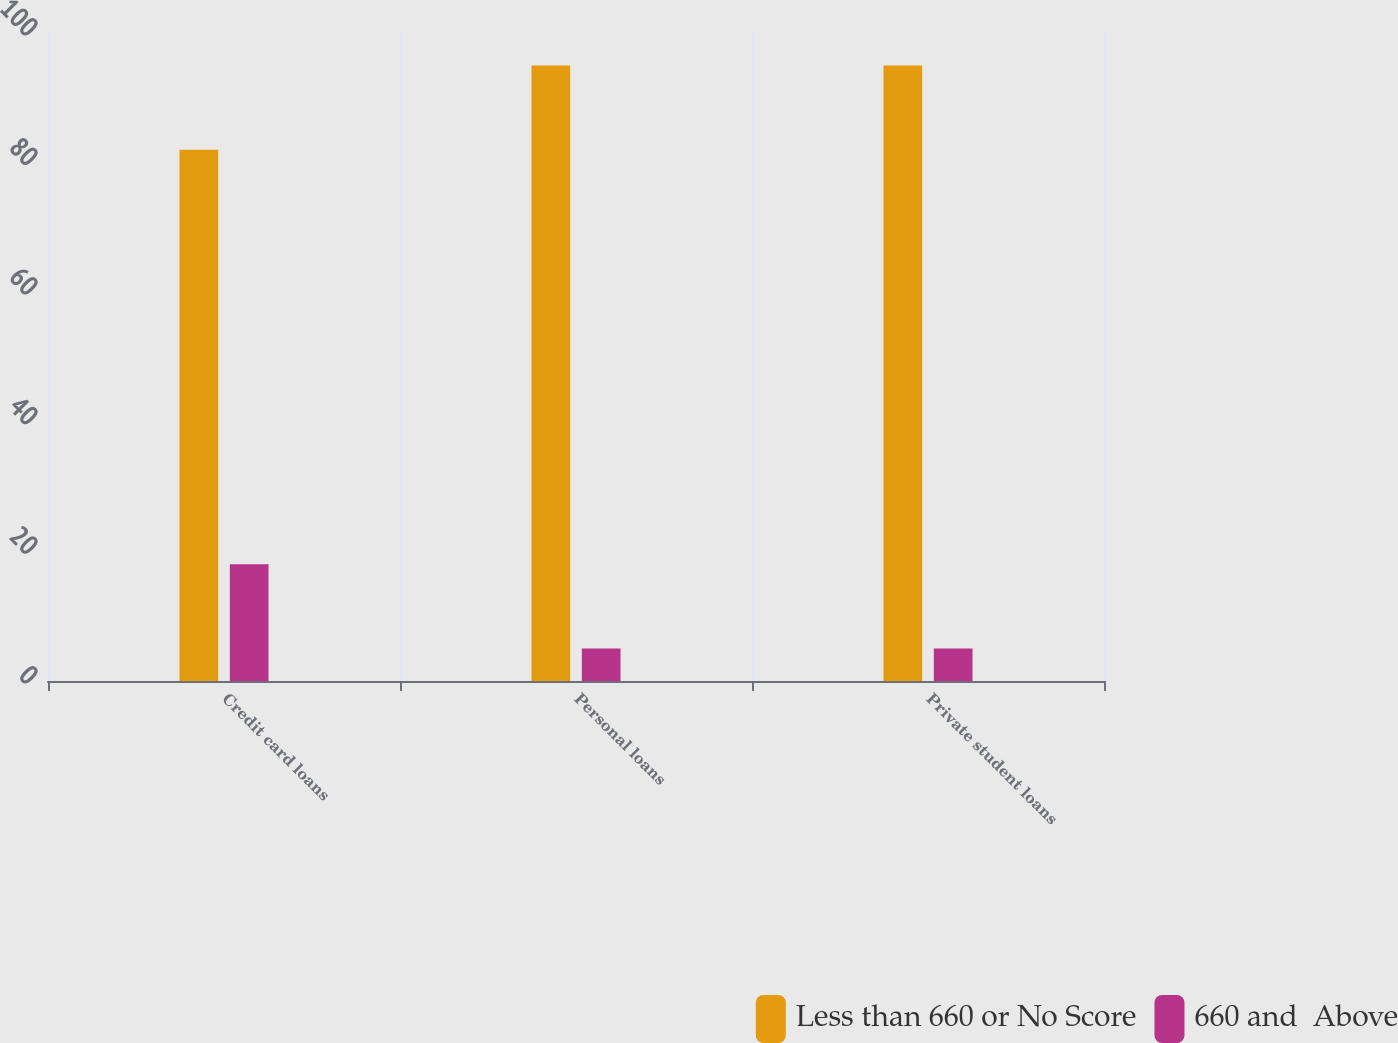Convert chart. <chart><loc_0><loc_0><loc_500><loc_500><stacked_bar_chart><ecel><fcel>Credit card loans<fcel>Personal loans<fcel>Private student loans<nl><fcel>Less than 660 or No Score<fcel>82<fcel>95<fcel>95<nl><fcel>660 and  Above<fcel>18<fcel>5<fcel>5<nl></chart> 